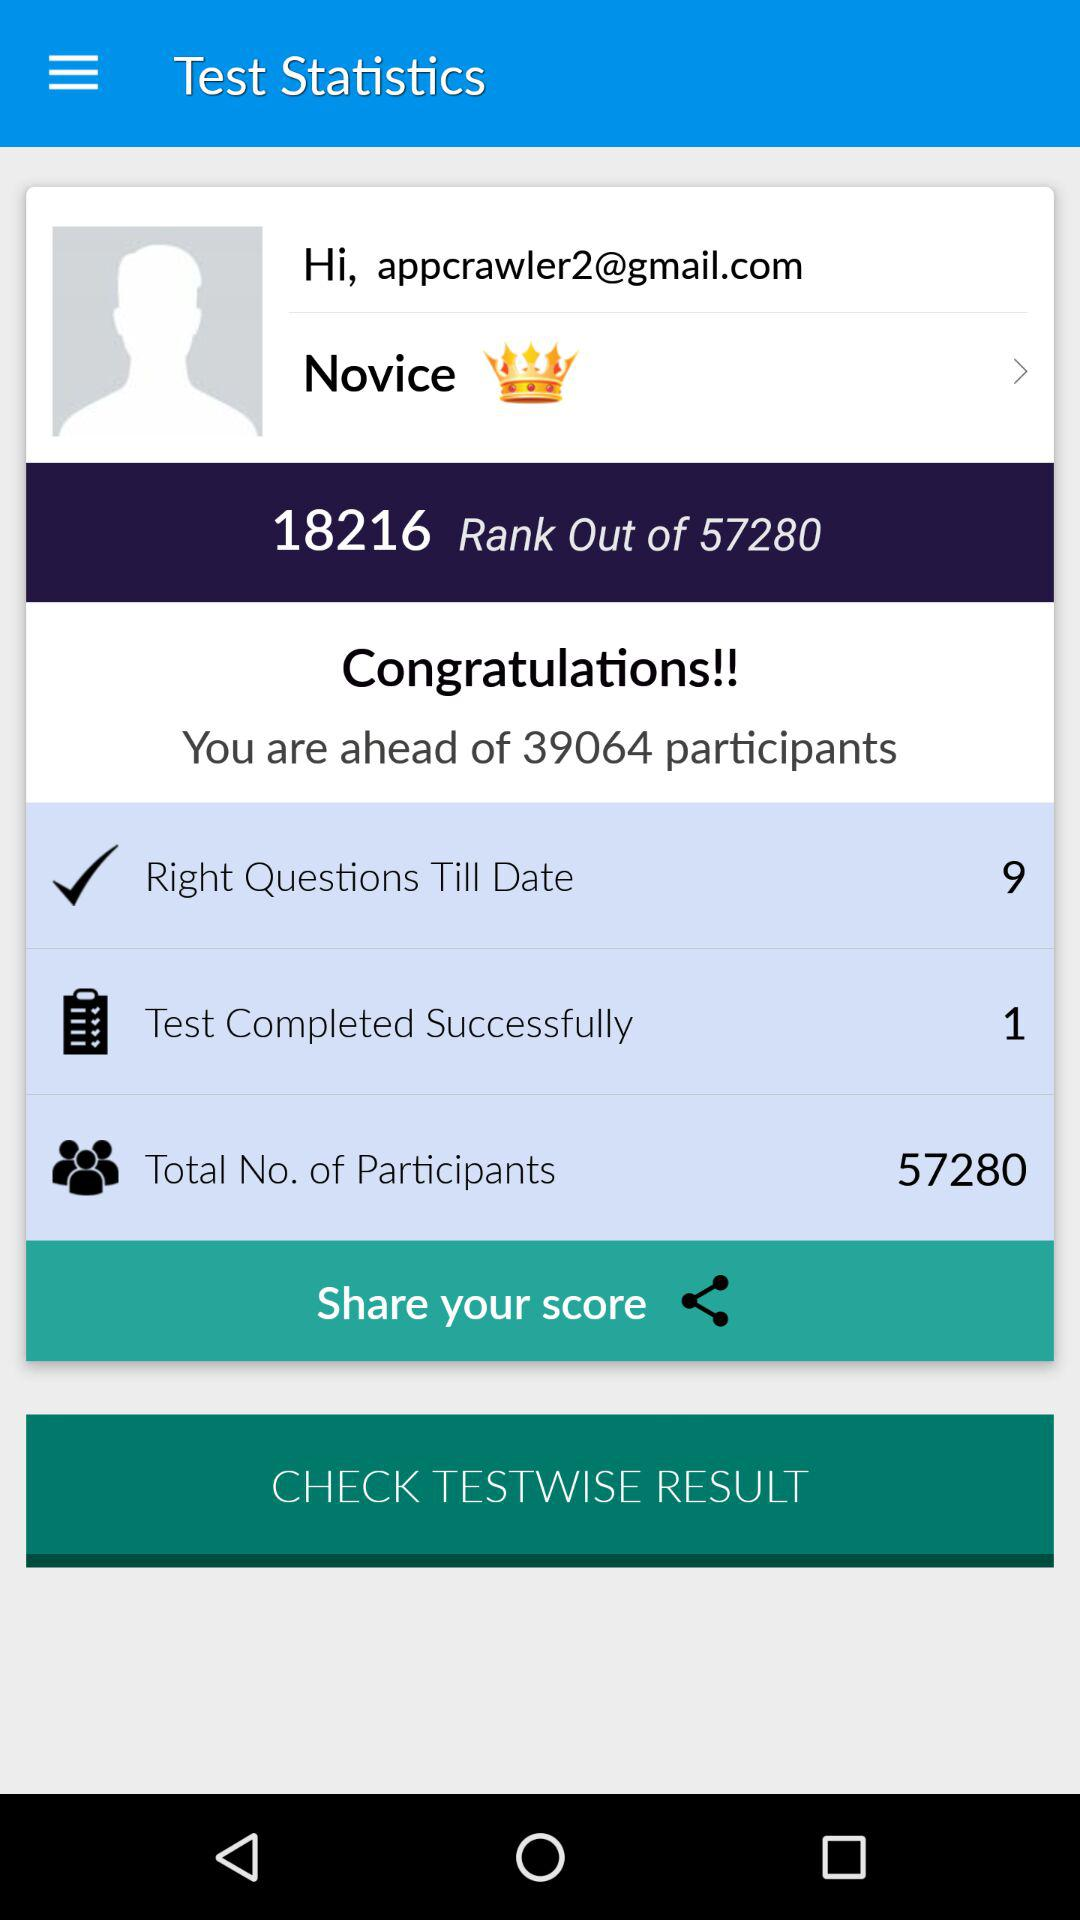How many participants is the user ahead of? The user is ahead of 39064 participants. 